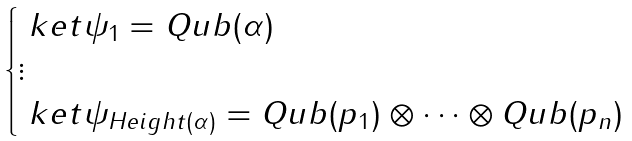Convert formula to latex. <formula><loc_0><loc_0><loc_500><loc_500>\begin{cases} \ k e t { \psi _ { 1 } } = Q u b ( \alpha ) \\ \vdots \\ \ k e t { \psi _ { H e i g h t ( \alpha ) } } = Q u b ( p _ { 1 } ) \otimes \dots \otimes Q u b ( p _ { n } ) \end{cases}</formula> 